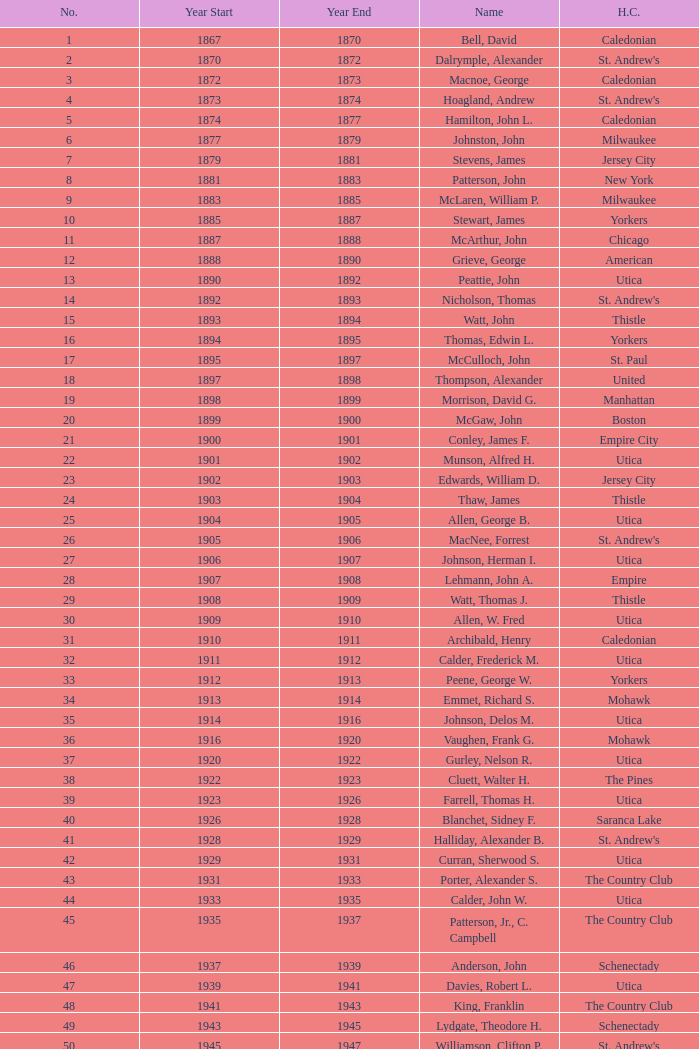Which Number has a Year Start smaller than 1874, and a Year End larger than 1873? 4.0. 